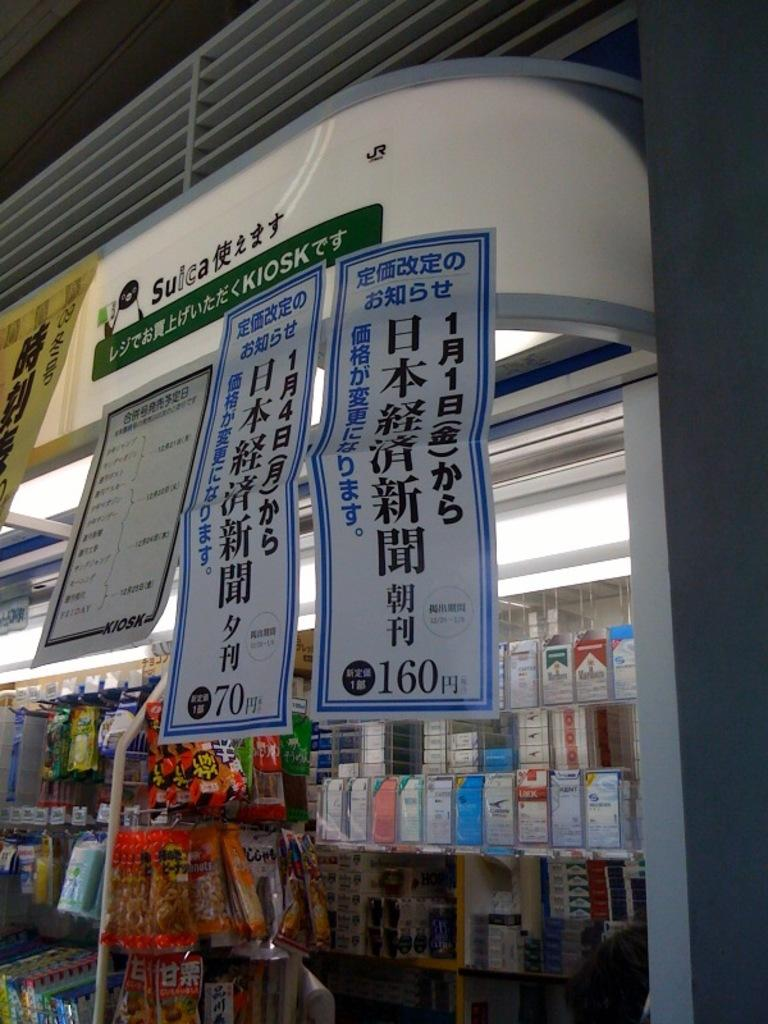<image>
Render a clear and concise summary of the photo. a shop display with Chinese Letters reading KIOSK with things for sale 